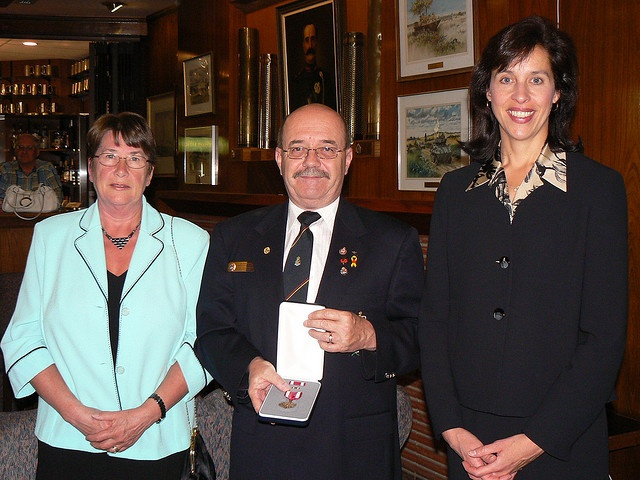Describe the objects in this image and their specific colors. I can see people in black, salmon, and brown tones, people in black, lightblue, and brown tones, people in black, white, salmon, and brown tones, people in black, maroon, and gray tones, and tie in black and gray tones in this image. 